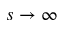<formula> <loc_0><loc_0><loc_500><loc_500>s \rightarrow \infty</formula> 